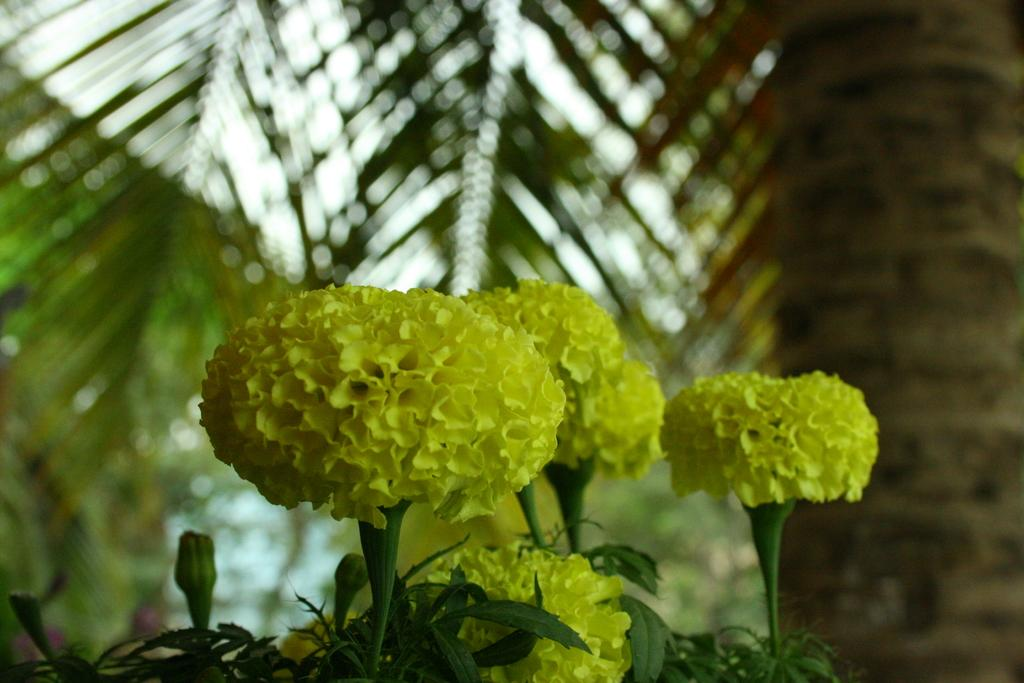What is located in the middle of the picture? There are flowers in the middle of the picture. What can be seen in the background of the picture? There are trees in the background of the picture. What type of bread can be seen growing on the coast in the image? There is no bread or coast present in the image; it features flowers in the middle and trees in the background. 